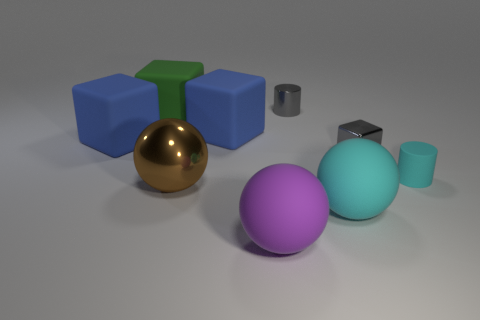How many green objects are rubber cubes or big metal balls?
Keep it short and to the point. 1. Does the cube that is right of the purple matte thing have the same color as the matte cylinder?
Keep it short and to the point. No. The purple thing that is the same material as the large green cube is what shape?
Provide a succinct answer. Sphere. There is a block that is both to the right of the metallic sphere and behind the small gray block; what color is it?
Offer a very short reply. Blue. What size is the gray object to the left of the cyan object that is to the left of the tiny gray cube?
Your response must be concise. Small. Is there a big metal sphere that has the same color as the shiny cylinder?
Give a very brief answer. No. Is the number of small shiny objects to the right of the metal block the same as the number of small cyan matte balls?
Your answer should be compact. Yes. What number of large purple rubber spheres are there?
Give a very brief answer. 1. There is a metal object that is both behind the brown sphere and to the left of the tiny gray shiny block; what shape is it?
Your answer should be compact. Cylinder. Is the color of the small cylinder that is behind the tiny cyan cylinder the same as the small shiny cube in front of the metallic cylinder?
Your response must be concise. Yes. 